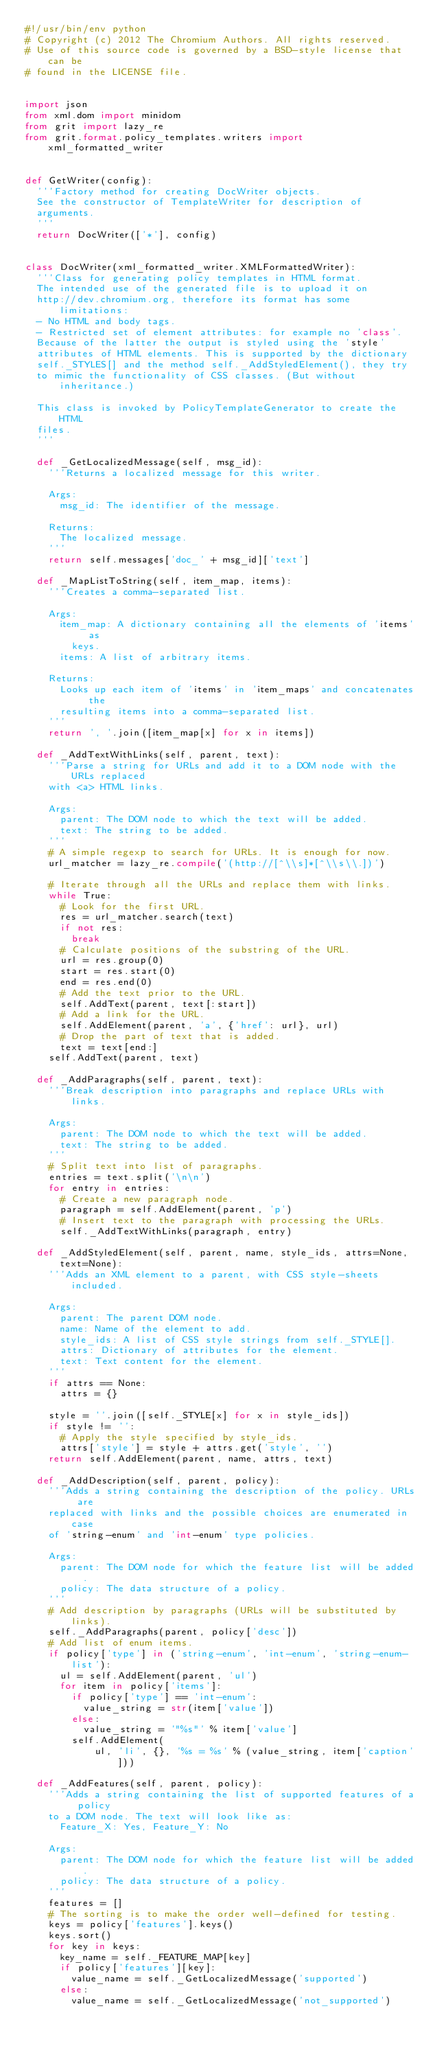Convert code to text. <code><loc_0><loc_0><loc_500><loc_500><_Python_>#!/usr/bin/env python
# Copyright (c) 2012 The Chromium Authors. All rights reserved.
# Use of this source code is governed by a BSD-style license that can be
# found in the LICENSE file.


import json
from xml.dom import minidom
from grit import lazy_re
from grit.format.policy_templates.writers import xml_formatted_writer


def GetWriter(config):
  '''Factory method for creating DocWriter objects.
  See the constructor of TemplateWriter for description of
  arguments.
  '''
  return DocWriter(['*'], config)


class DocWriter(xml_formatted_writer.XMLFormattedWriter):
  '''Class for generating policy templates in HTML format.
  The intended use of the generated file is to upload it on
  http://dev.chromium.org, therefore its format has some limitations:
  - No HTML and body tags.
  - Restricted set of element attributes: for example no 'class'.
  Because of the latter the output is styled using the 'style'
  attributes of HTML elements. This is supported by the dictionary
  self._STYLES[] and the method self._AddStyledElement(), they try
  to mimic the functionality of CSS classes. (But without inheritance.)

  This class is invoked by PolicyTemplateGenerator to create the HTML
  files.
  '''

  def _GetLocalizedMessage(self, msg_id):
    '''Returns a localized message for this writer.

    Args:
      msg_id: The identifier of the message.

    Returns:
      The localized message.
    '''
    return self.messages['doc_' + msg_id]['text']

  def _MapListToString(self, item_map, items):
    '''Creates a comma-separated list.

    Args:
      item_map: A dictionary containing all the elements of 'items' as
        keys.
      items: A list of arbitrary items.

    Returns:
      Looks up each item of 'items' in 'item_maps' and concatenates the
      resulting items into a comma-separated list.
    '''
    return ', '.join([item_map[x] for x in items])

  def _AddTextWithLinks(self, parent, text):
    '''Parse a string for URLs and add it to a DOM node with the URLs replaced
    with <a> HTML links.

    Args:
      parent: The DOM node to which the text will be added.
      text: The string to be added.
    '''
    # A simple regexp to search for URLs. It is enough for now.
    url_matcher = lazy_re.compile('(http://[^\\s]*[^\\s\\.])')

    # Iterate through all the URLs and replace them with links.
    while True:
      # Look for the first URL.
      res = url_matcher.search(text)
      if not res:
        break
      # Calculate positions of the substring of the URL.
      url = res.group(0)
      start = res.start(0)
      end = res.end(0)
      # Add the text prior to the URL.
      self.AddText(parent, text[:start])
      # Add a link for the URL.
      self.AddElement(parent, 'a', {'href': url}, url)
      # Drop the part of text that is added.
      text = text[end:]
    self.AddText(parent, text)

  def _AddParagraphs(self, parent, text):
    '''Break description into paragraphs and replace URLs with links.

    Args:
      parent: The DOM node to which the text will be added.
      text: The string to be added.
    '''
    # Split text into list of paragraphs.
    entries = text.split('\n\n')
    for entry in entries:
      # Create a new paragraph node.
      paragraph = self.AddElement(parent, 'p')
      # Insert text to the paragraph with processing the URLs.
      self._AddTextWithLinks(paragraph, entry)

  def _AddStyledElement(self, parent, name, style_ids, attrs=None, text=None):
    '''Adds an XML element to a parent, with CSS style-sheets included.

    Args:
      parent: The parent DOM node.
      name: Name of the element to add.
      style_ids: A list of CSS style strings from self._STYLE[].
      attrs: Dictionary of attributes for the element.
      text: Text content for the element.
    '''
    if attrs == None:
      attrs = {}

    style = ''.join([self._STYLE[x] for x in style_ids])
    if style != '':
      # Apply the style specified by style_ids.
      attrs['style'] = style + attrs.get('style', '')
    return self.AddElement(parent, name, attrs, text)

  def _AddDescription(self, parent, policy):
    '''Adds a string containing the description of the policy. URLs are
    replaced with links and the possible choices are enumerated in case
    of 'string-enum' and 'int-enum' type policies.

    Args:
      parent: The DOM node for which the feature list will be added.
      policy: The data structure of a policy.
    '''
    # Add description by paragraphs (URLs will be substituted by links).
    self._AddParagraphs(parent, policy['desc'])
    # Add list of enum items.
    if policy['type'] in ('string-enum', 'int-enum', 'string-enum-list'):
      ul = self.AddElement(parent, 'ul')
      for item in policy['items']:
        if policy['type'] == 'int-enum':
          value_string = str(item['value'])
        else:
          value_string = '"%s"' % item['value']
        self.AddElement(
            ul, 'li', {}, '%s = %s' % (value_string, item['caption']))

  def _AddFeatures(self, parent, policy):
    '''Adds a string containing the list of supported features of a policy
    to a DOM node. The text will look like as:
      Feature_X: Yes, Feature_Y: No

    Args:
      parent: The DOM node for which the feature list will be added.
      policy: The data structure of a policy.
    '''
    features = []
    # The sorting is to make the order well-defined for testing.
    keys = policy['features'].keys()
    keys.sort()
    for key in keys:
      key_name = self._FEATURE_MAP[key]
      if policy['features'][key]:
        value_name = self._GetLocalizedMessage('supported')
      else:
        value_name = self._GetLocalizedMessage('not_supported')</code> 